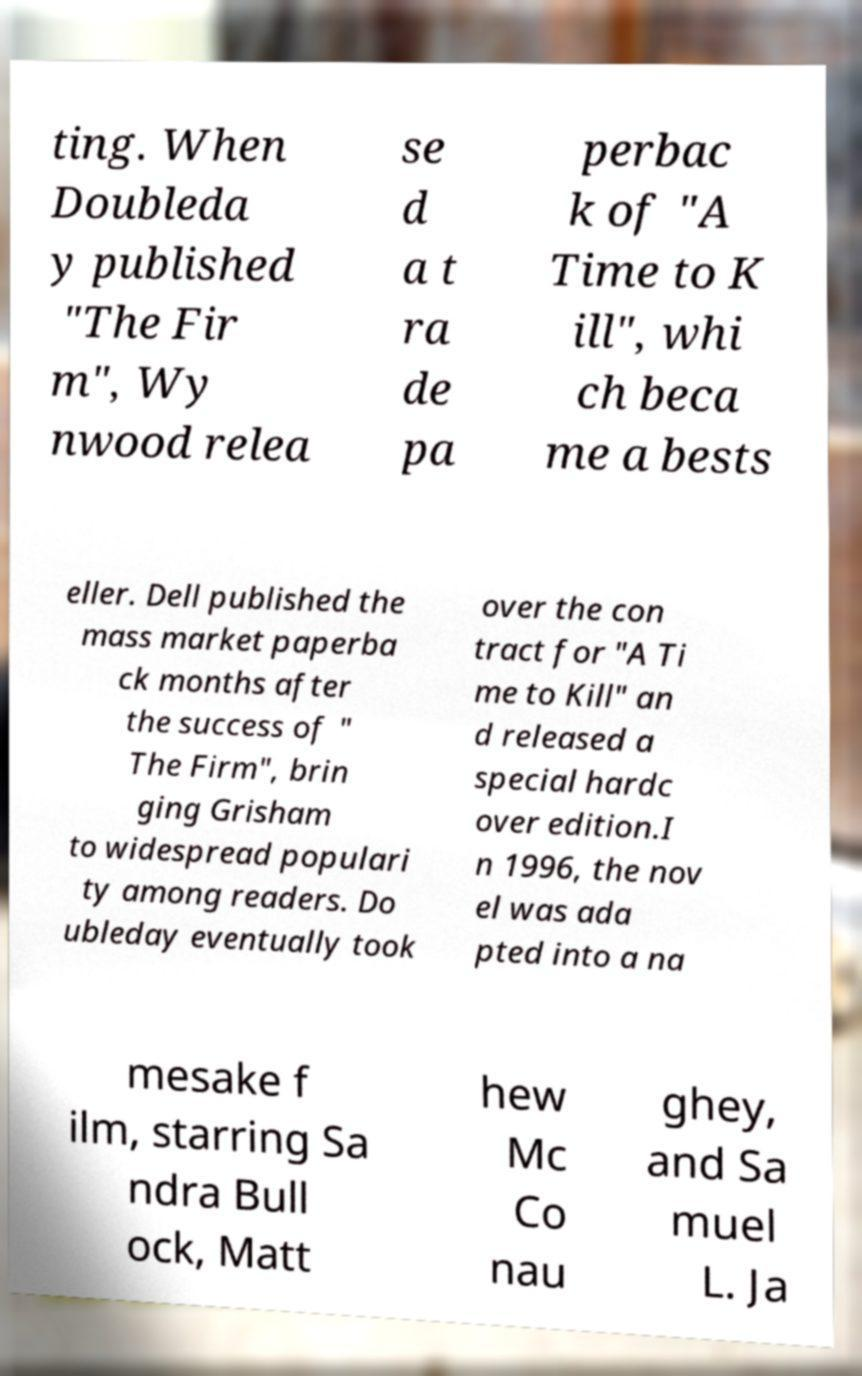Can you read and provide the text displayed in the image?This photo seems to have some interesting text. Can you extract and type it out for me? ting. When Doubleda y published "The Fir m", Wy nwood relea se d a t ra de pa perbac k of "A Time to K ill", whi ch beca me a bests eller. Dell published the mass market paperba ck months after the success of " The Firm", brin ging Grisham to widespread populari ty among readers. Do ubleday eventually took over the con tract for "A Ti me to Kill" an d released a special hardc over edition.I n 1996, the nov el was ada pted into a na mesake f ilm, starring Sa ndra Bull ock, Matt hew Mc Co nau ghey, and Sa muel L. Ja 